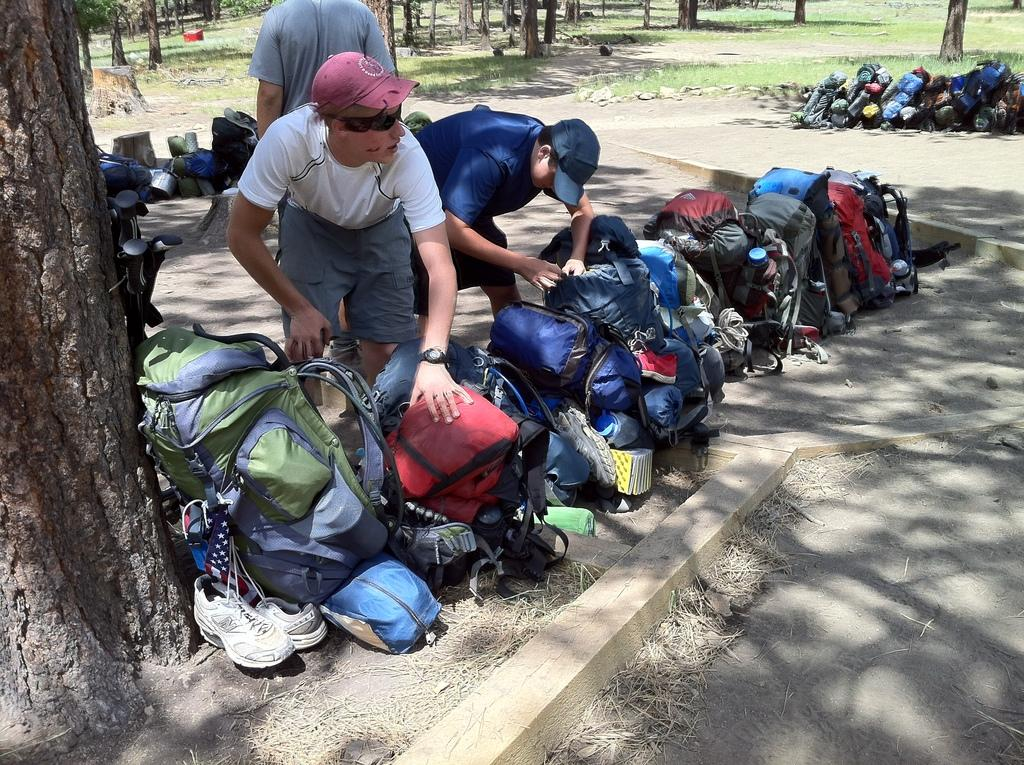How many men are present in the image? There are three men standing in the image. What items can be seen near the men? Bags and shoes are visible in the image. What objects are placed on the ground in the image? There are objects placed on the ground in the image. What type of vegetation is present in the image? The bark of trees and grass are present in the image. What other natural elements can be seen in the image? Stones are visible in the image. What type of education is being provided to the bread in the image? There is no bread present in the image, and therefore no education can be provided to it. 